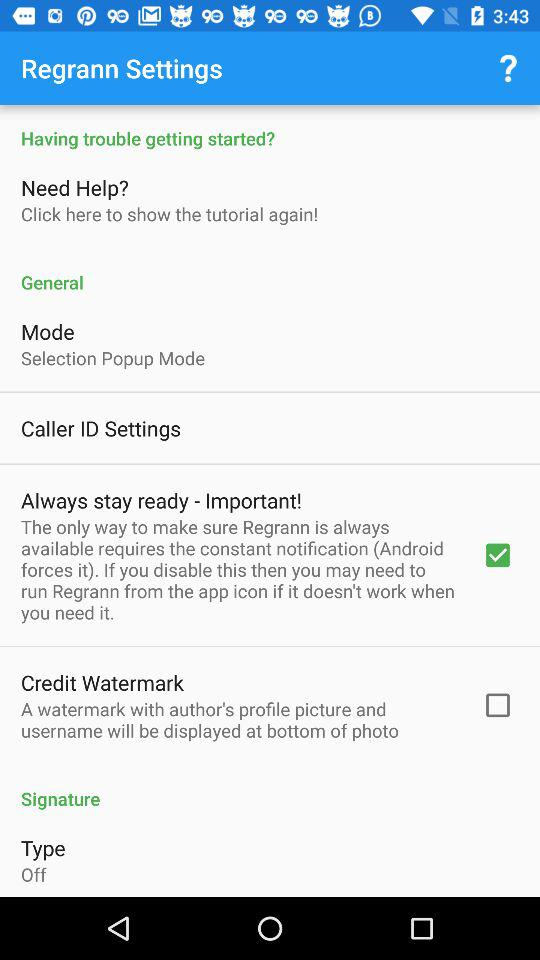What is the selected mode? The selected mode is "Selection Popup Mode". 